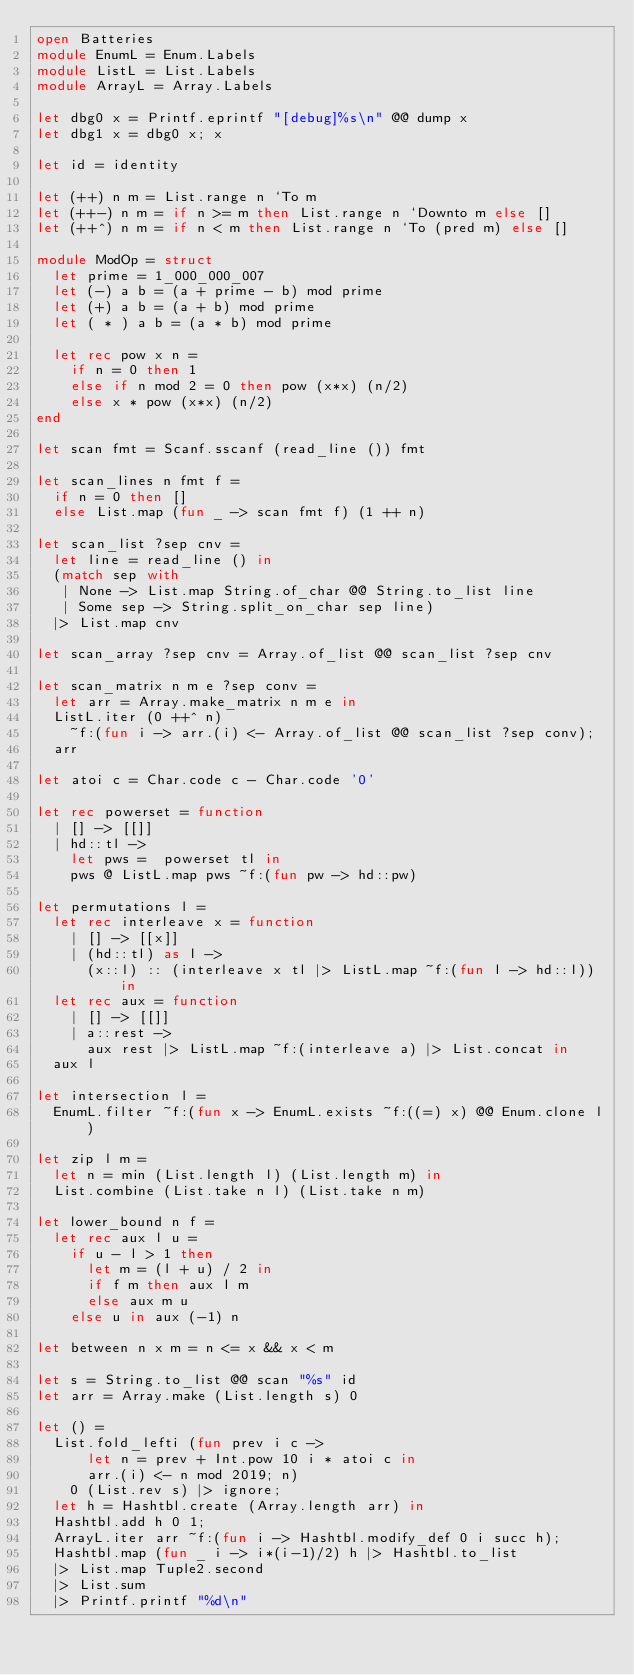<code> <loc_0><loc_0><loc_500><loc_500><_OCaml_>open Batteries
module EnumL = Enum.Labels
module ListL = List.Labels
module ArrayL = Array.Labels

let dbg0 x = Printf.eprintf "[debug]%s\n" @@ dump x
let dbg1 x = dbg0 x; x

let id = identity

let (++) n m = List.range n `To m
let (++-) n m = if n >= m then List.range n `Downto m else []
let (++^) n m = if n < m then List.range n `To (pred m) else []

module ModOp = struct
  let prime = 1_000_000_007
  let (-) a b = (a + prime - b) mod prime
  let (+) a b = (a + b) mod prime
  let ( * ) a b = (a * b) mod prime

  let rec pow x n =
    if n = 0 then 1
    else if n mod 2 = 0 then pow (x*x) (n/2)
    else x * pow (x*x) (n/2)
end

let scan fmt = Scanf.sscanf (read_line ()) fmt

let scan_lines n fmt f =
  if n = 0 then []
  else List.map (fun _ -> scan fmt f) (1 ++ n)

let scan_list ?sep cnv =
  let line = read_line () in
  (match sep with
   | None -> List.map String.of_char @@ String.to_list line
   | Some sep -> String.split_on_char sep line)
  |> List.map cnv

let scan_array ?sep cnv = Array.of_list @@ scan_list ?sep cnv

let scan_matrix n m e ?sep conv =
  let arr = Array.make_matrix n m e in
  ListL.iter (0 ++^ n)
    ~f:(fun i -> arr.(i) <- Array.of_list @@ scan_list ?sep conv);
  arr

let atoi c = Char.code c - Char.code '0'

let rec powerset = function
  | [] -> [[]]
  | hd::tl ->
    let pws =  powerset tl in
    pws @ ListL.map pws ~f:(fun pw -> hd::pw)

let permutations l =
  let rec interleave x = function
    | [] -> [[x]]
    | (hd::tl) as l ->
      (x::l) :: (interleave x tl |> ListL.map ~f:(fun l -> hd::l)) in
  let rec aux = function
    | [] -> [[]]
    | a::rest ->
      aux rest |> ListL.map ~f:(interleave a) |> List.concat in
  aux l

let intersection l =
  EnumL.filter ~f:(fun x -> EnumL.exists ~f:((=) x) @@ Enum.clone l)

let zip l m =
  let n = min (List.length l) (List.length m) in
  List.combine (List.take n l) (List.take n m)

let lower_bound n f =
  let rec aux l u =
    if u - l > 1 then
      let m = (l + u) / 2 in
      if f m then aux l m
      else aux m u
    else u in aux (-1) n

let between n x m = n <= x && x < m

let s = String.to_list @@ scan "%s" id
let arr = Array.make (List.length s) 0

let () =
  List.fold_lefti (fun prev i c ->
      let n = prev + Int.pow 10 i * atoi c in
      arr.(i) <- n mod 2019; n)
    0 (List.rev s) |> ignore;
  let h = Hashtbl.create (Array.length arr) in
  Hashtbl.add h 0 1;
  ArrayL.iter arr ~f:(fun i -> Hashtbl.modify_def 0 i succ h);
  Hashtbl.map (fun _ i -> i*(i-1)/2) h |> Hashtbl.to_list
  |> List.map Tuple2.second
  |> List.sum
  |> Printf.printf "%d\n"
</code> 